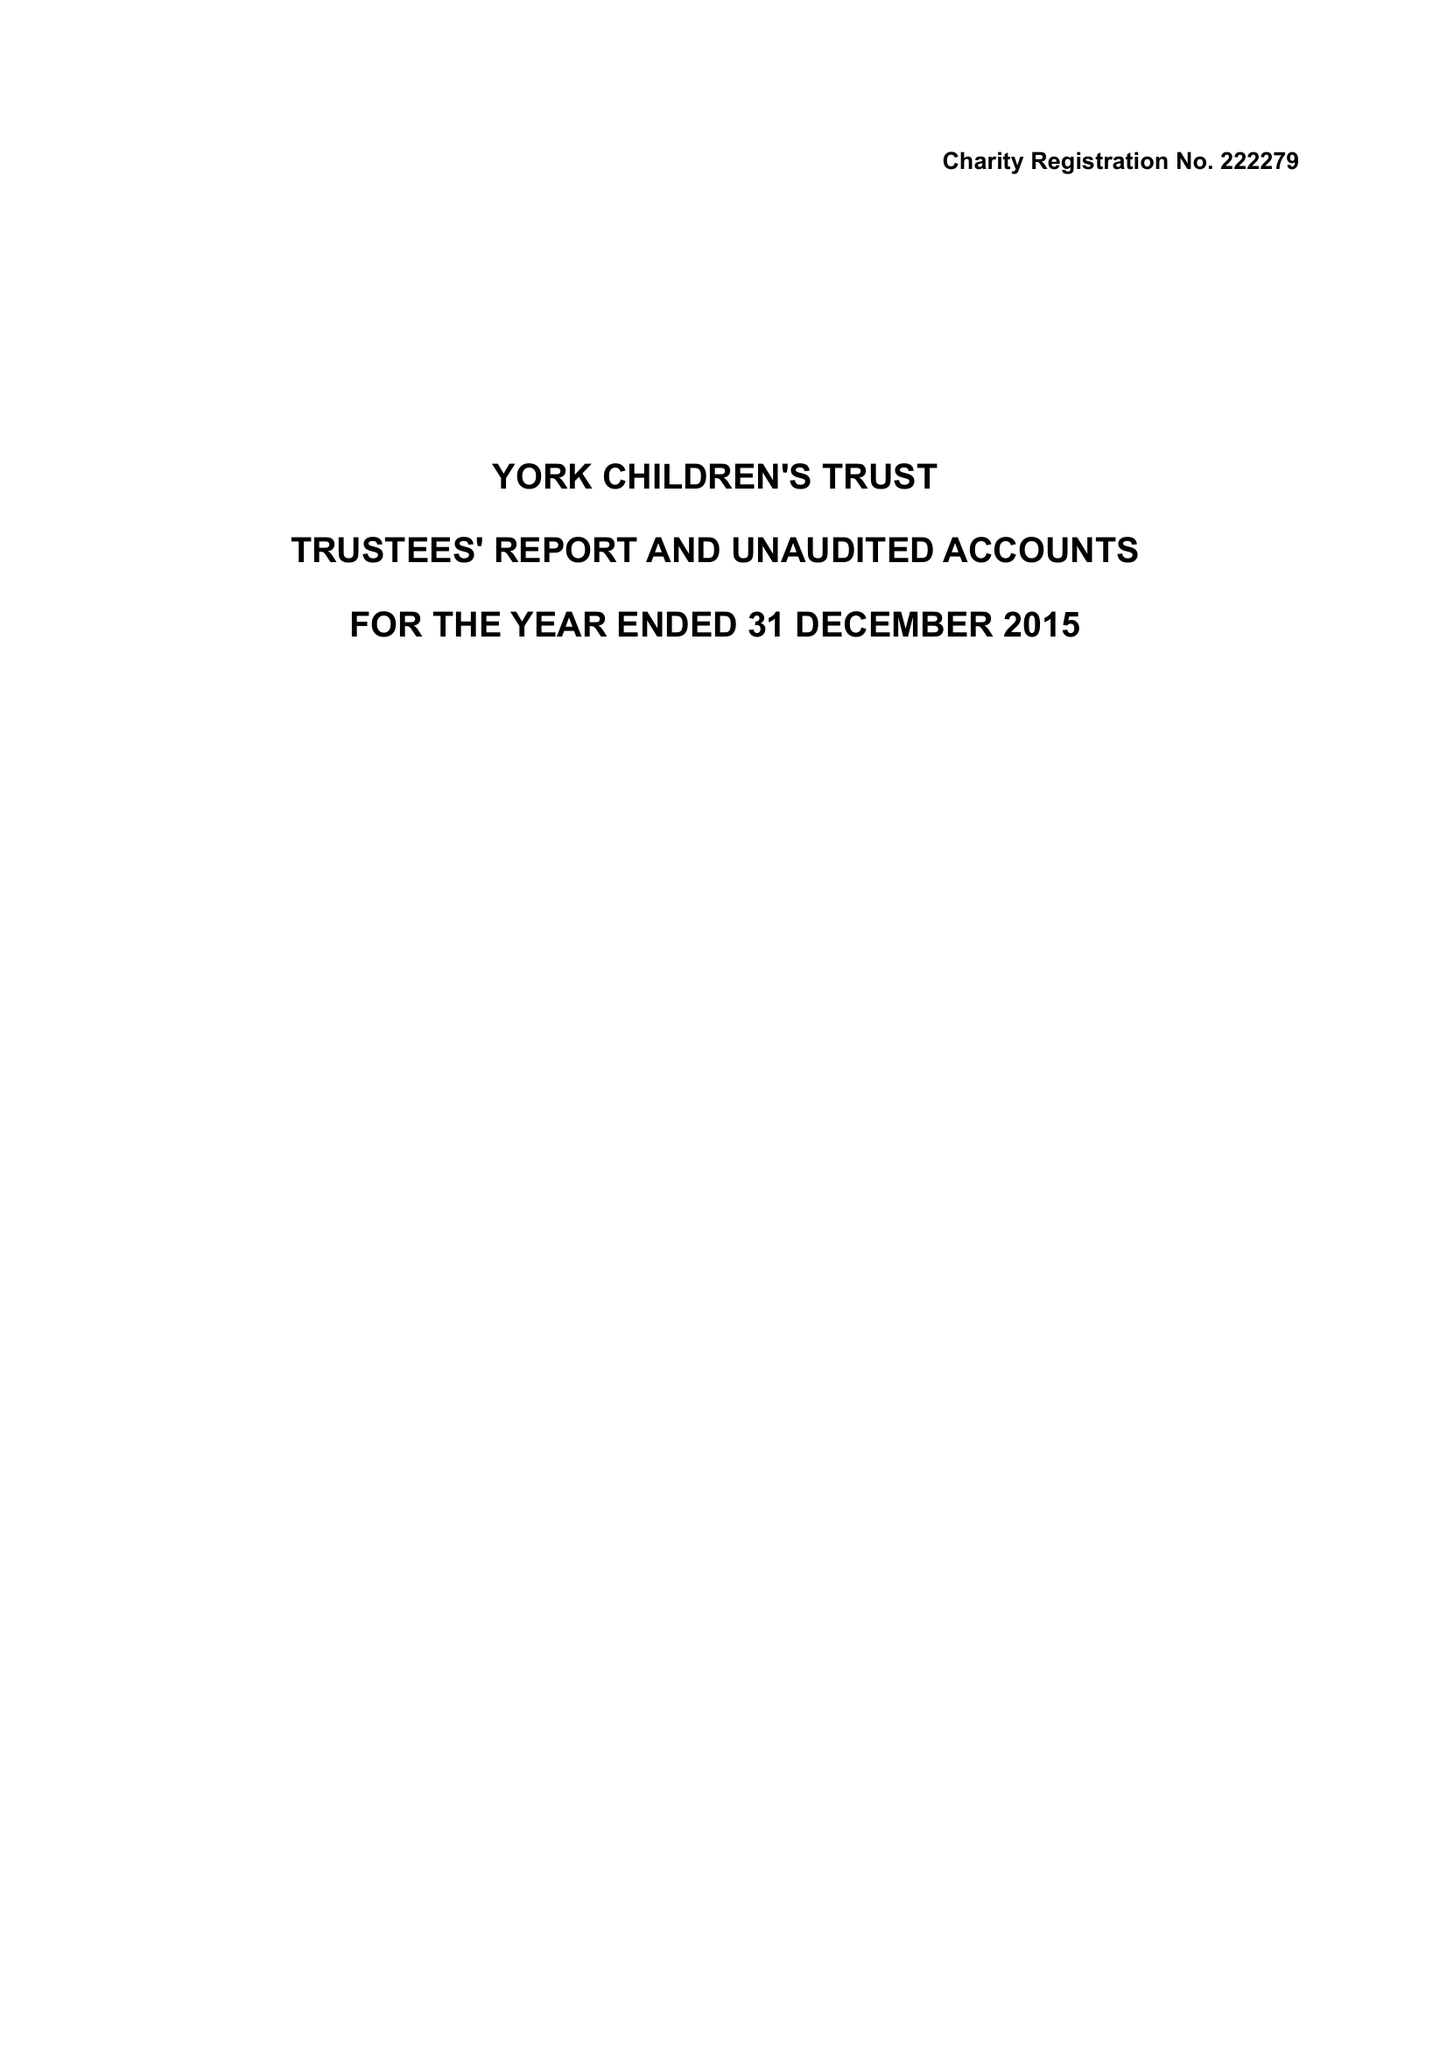What is the value for the address__post_town?
Answer the question using a single word or phrase. HARROGATE 